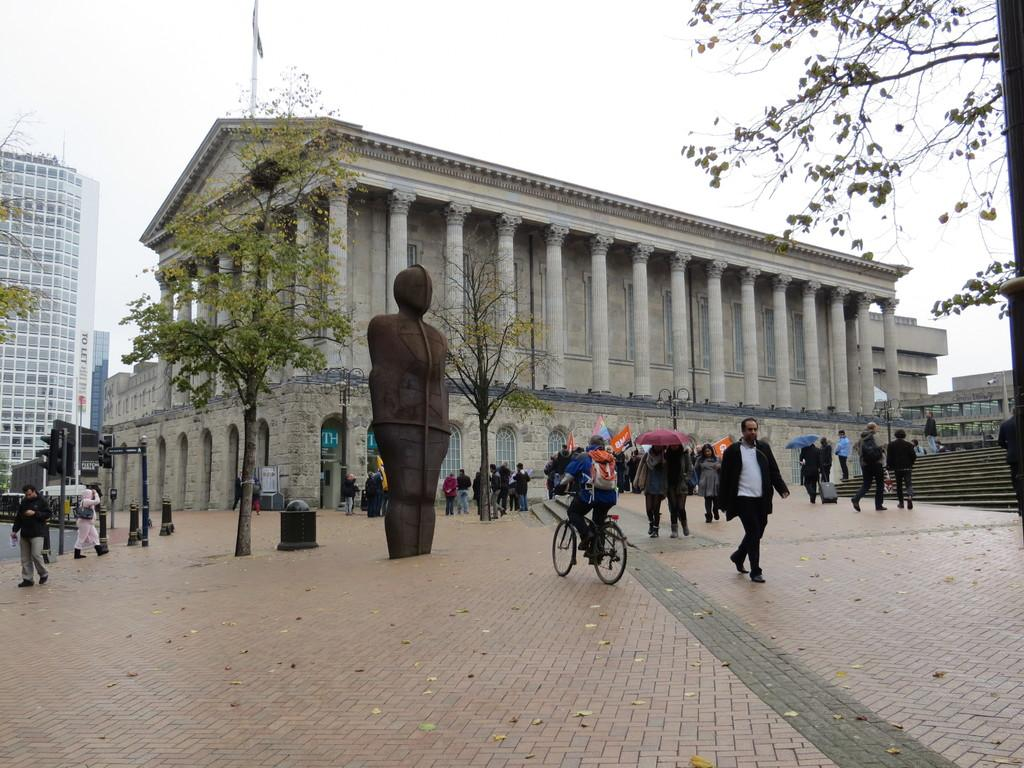What type of structure is depicted in the image? There is a building with pillars in the image. What is located at the bottom of the image? There is a road at the bottom of the image. What are the people in the image doing? Many people are walking on the road. What can be seen to the left of the building with pillars? There is another building to the left of the image. What is visible at the top of the image? The sky is visible at the top of the image. What type of hammer is being used to fix the system in the image? There is no hammer or system present in the image; it features a building with pillars, a road, people walking, and a sky. 